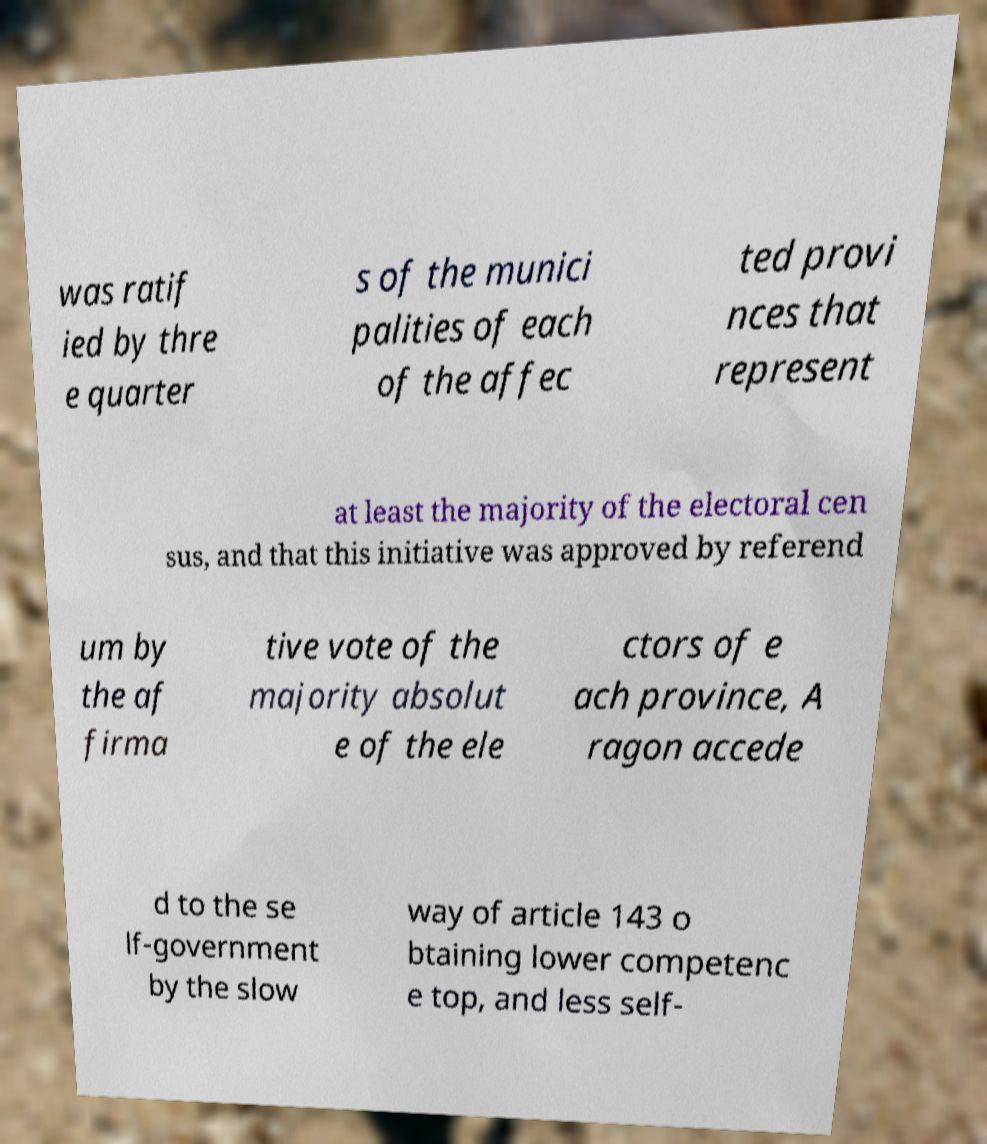Could you assist in decoding the text presented in this image and type it out clearly? was ratif ied by thre e quarter s of the munici palities of each of the affec ted provi nces that represent at least the majority of the electoral cen sus, and that this initiative was approved by referend um by the af firma tive vote of the majority absolut e of the ele ctors of e ach province, A ragon accede d to the se lf-government by the slow way of article 143 o btaining lower competenc e top, and less self- 